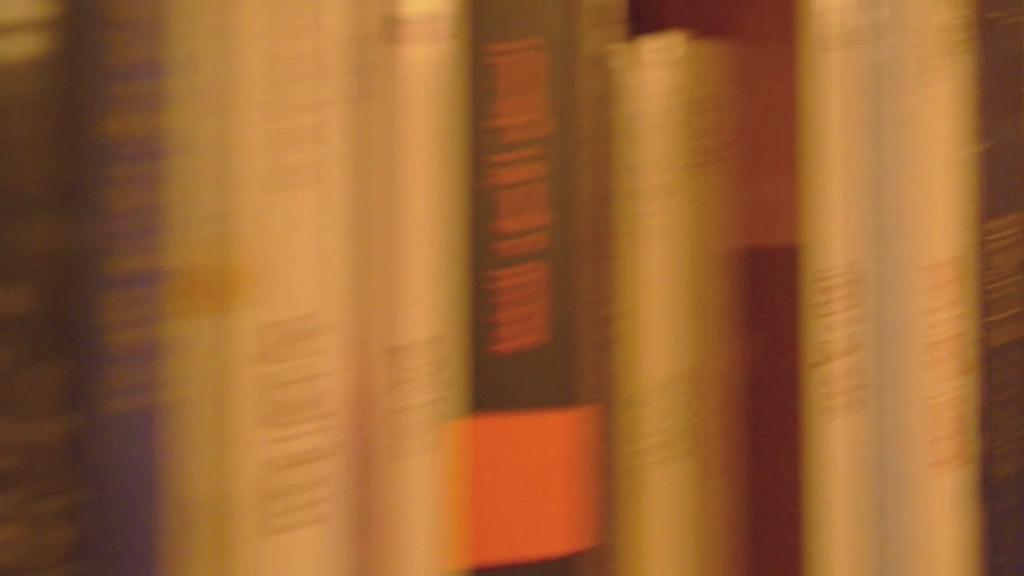What objects are present in the image? There are books in the image. What can be seen on the books? There is text on the books. What type of history can be learned from the mountain in the image? There is no mountain present in the image, so it is not possible to learn any history from it. 